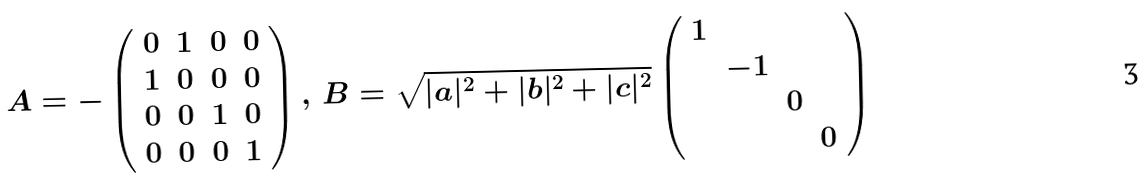<formula> <loc_0><loc_0><loc_500><loc_500>A = - \left ( \begin{array} { c c c c } 0 & 1 & 0 & 0 \\ 1 & 0 & 0 & 0 \\ 0 & 0 & 1 & 0 \\ 0 & 0 & 0 & 1 \end{array} \right ) , \, B = \sqrt { | a | ^ { 2 } + | b | ^ { 2 } + | c | ^ { 2 } } \left ( \begin{array} { c c c c } 1 & & & \\ & - 1 & & \\ & & 0 & \\ & & & 0 \end{array} \right )</formula> 